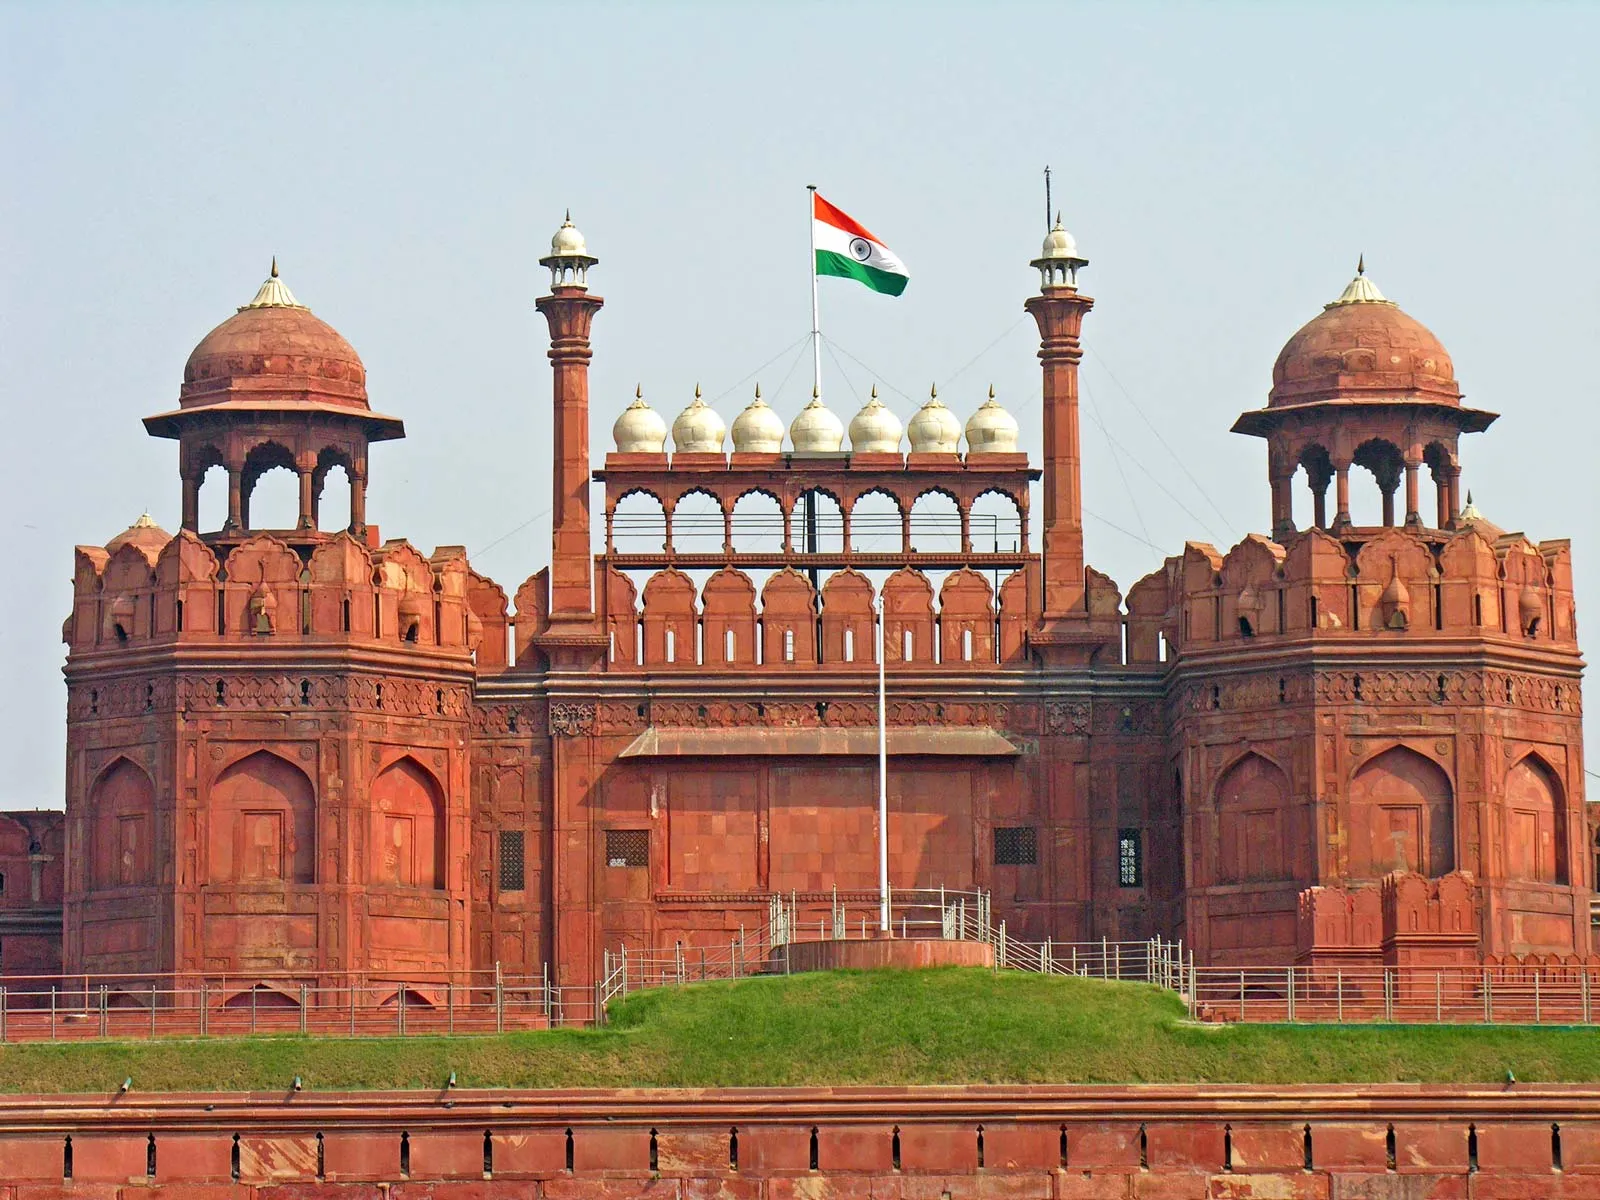Imagine this fort during its peak centuries ago. What would the scene be like? During its peak in the Mughal era, the Red Fort would have been a hub of activity and grandeur. The smell of exotic spices and the sound of bustling markets would fill the air. Elephants adorned with jewels, troops of soldiers, and courtiers in lavish garments would be seen roaming the grounds. The fort’s halls would resonate with the sound of music and poetry, reflecting the rich cultural life of the period. Royal processions and ceremonies would be a common sight, showcasing the opulence and power of the Mughal Empire. The gardens would be meticulously maintained, teeming with vibrant flowers and fountains. Overall, it would be a vivid display of architecture, culture, and imperial authority. 